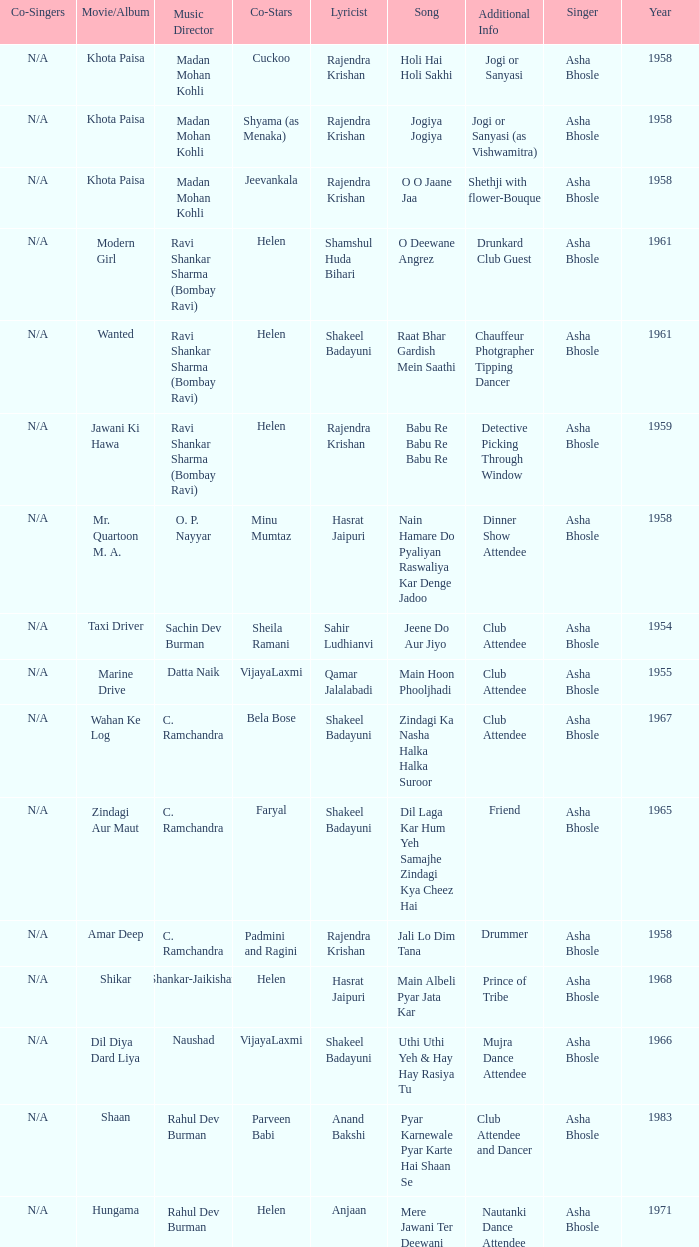What year did Naushad Direct the Music? 1966.0. 